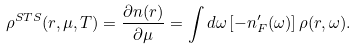Convert formula to latex. <formula><loc_0><loc_0><loc_500><loc_500>\rho ^ { S T S } ( { r } , \mu , T ) = \frac { \partial n ( { r } ) } { \partial \mu } = \int d \omega \left [ - n ^ { \prime } _ { F } ( \omega ) \right ] \rho ( { r } , \omega ) .</formula> 